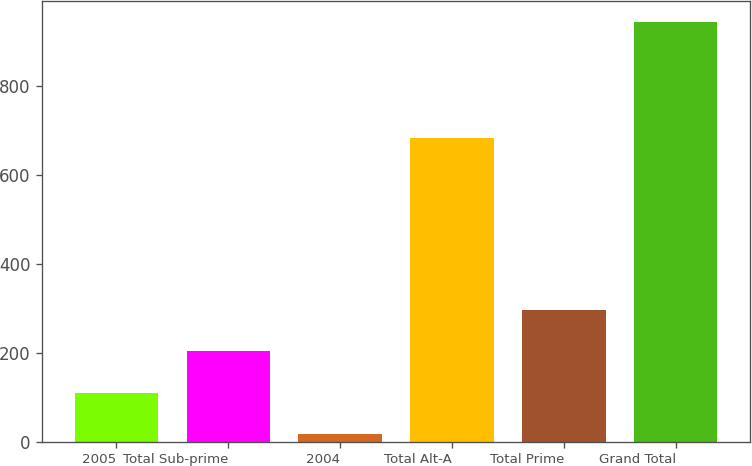Convert chart to OTSL. <chart><loc_0><loc_0><loc_500><loc_500><bar_chart><fcel>2005<fcel>Total Sub-prime<fcel>2004<fcel>Total Alt-A<fcel>Total Prime<fcel>Grand Total<nl><fcel>109.7<fcel>202.4<fcel>17<fcel>683<fcel>295.1<fcel>944<nl></chart> 